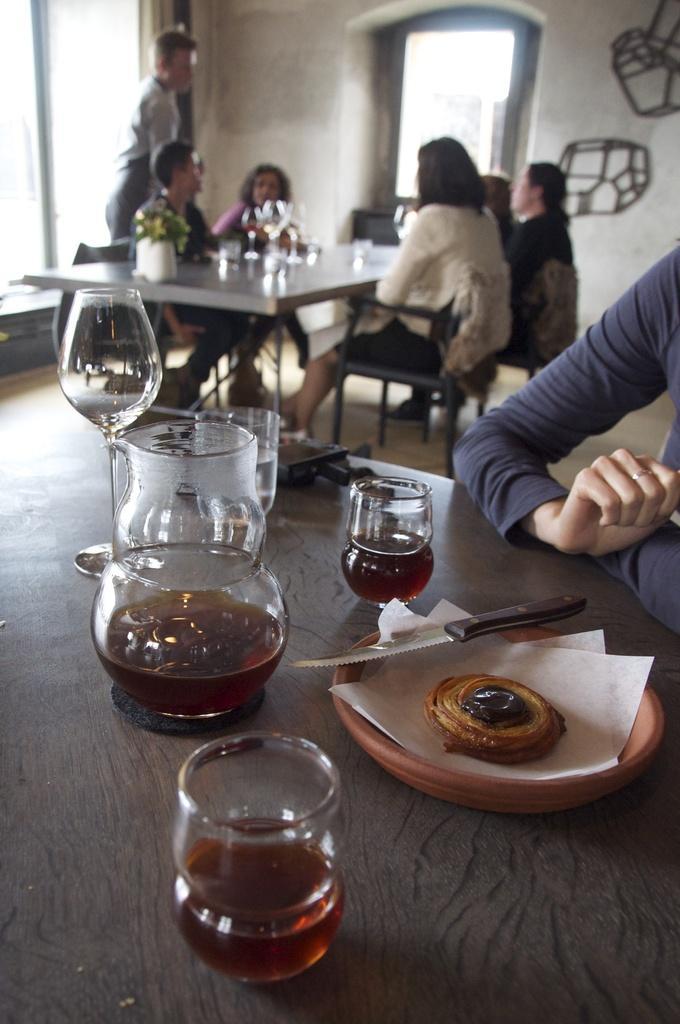Could you give a brief overview of what you see in this image? In this picture we can see some persons sitting on chair and one is standing and here on table we can see glasses, plate, knife, some food, jar and in background we can see wall, door. 